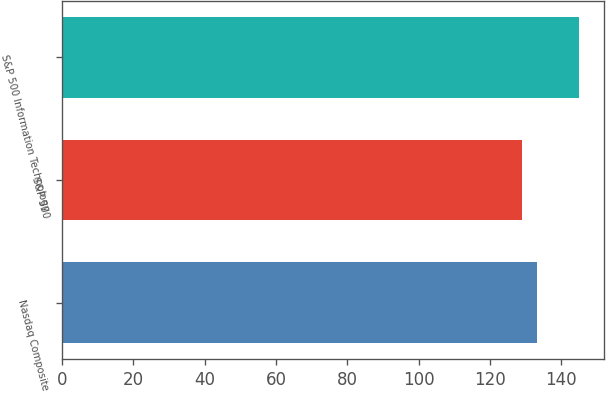Convert chart. <chart><loc_0><loc_0><loc_500><loc_500><bar_chart><fcel>Nasdaq Composite<fcel>S&P 500<fcel>S&P 500 Information Technology<nl><fcel>133.19<fcel>129.05<fcel>144.85<nl></chart> 